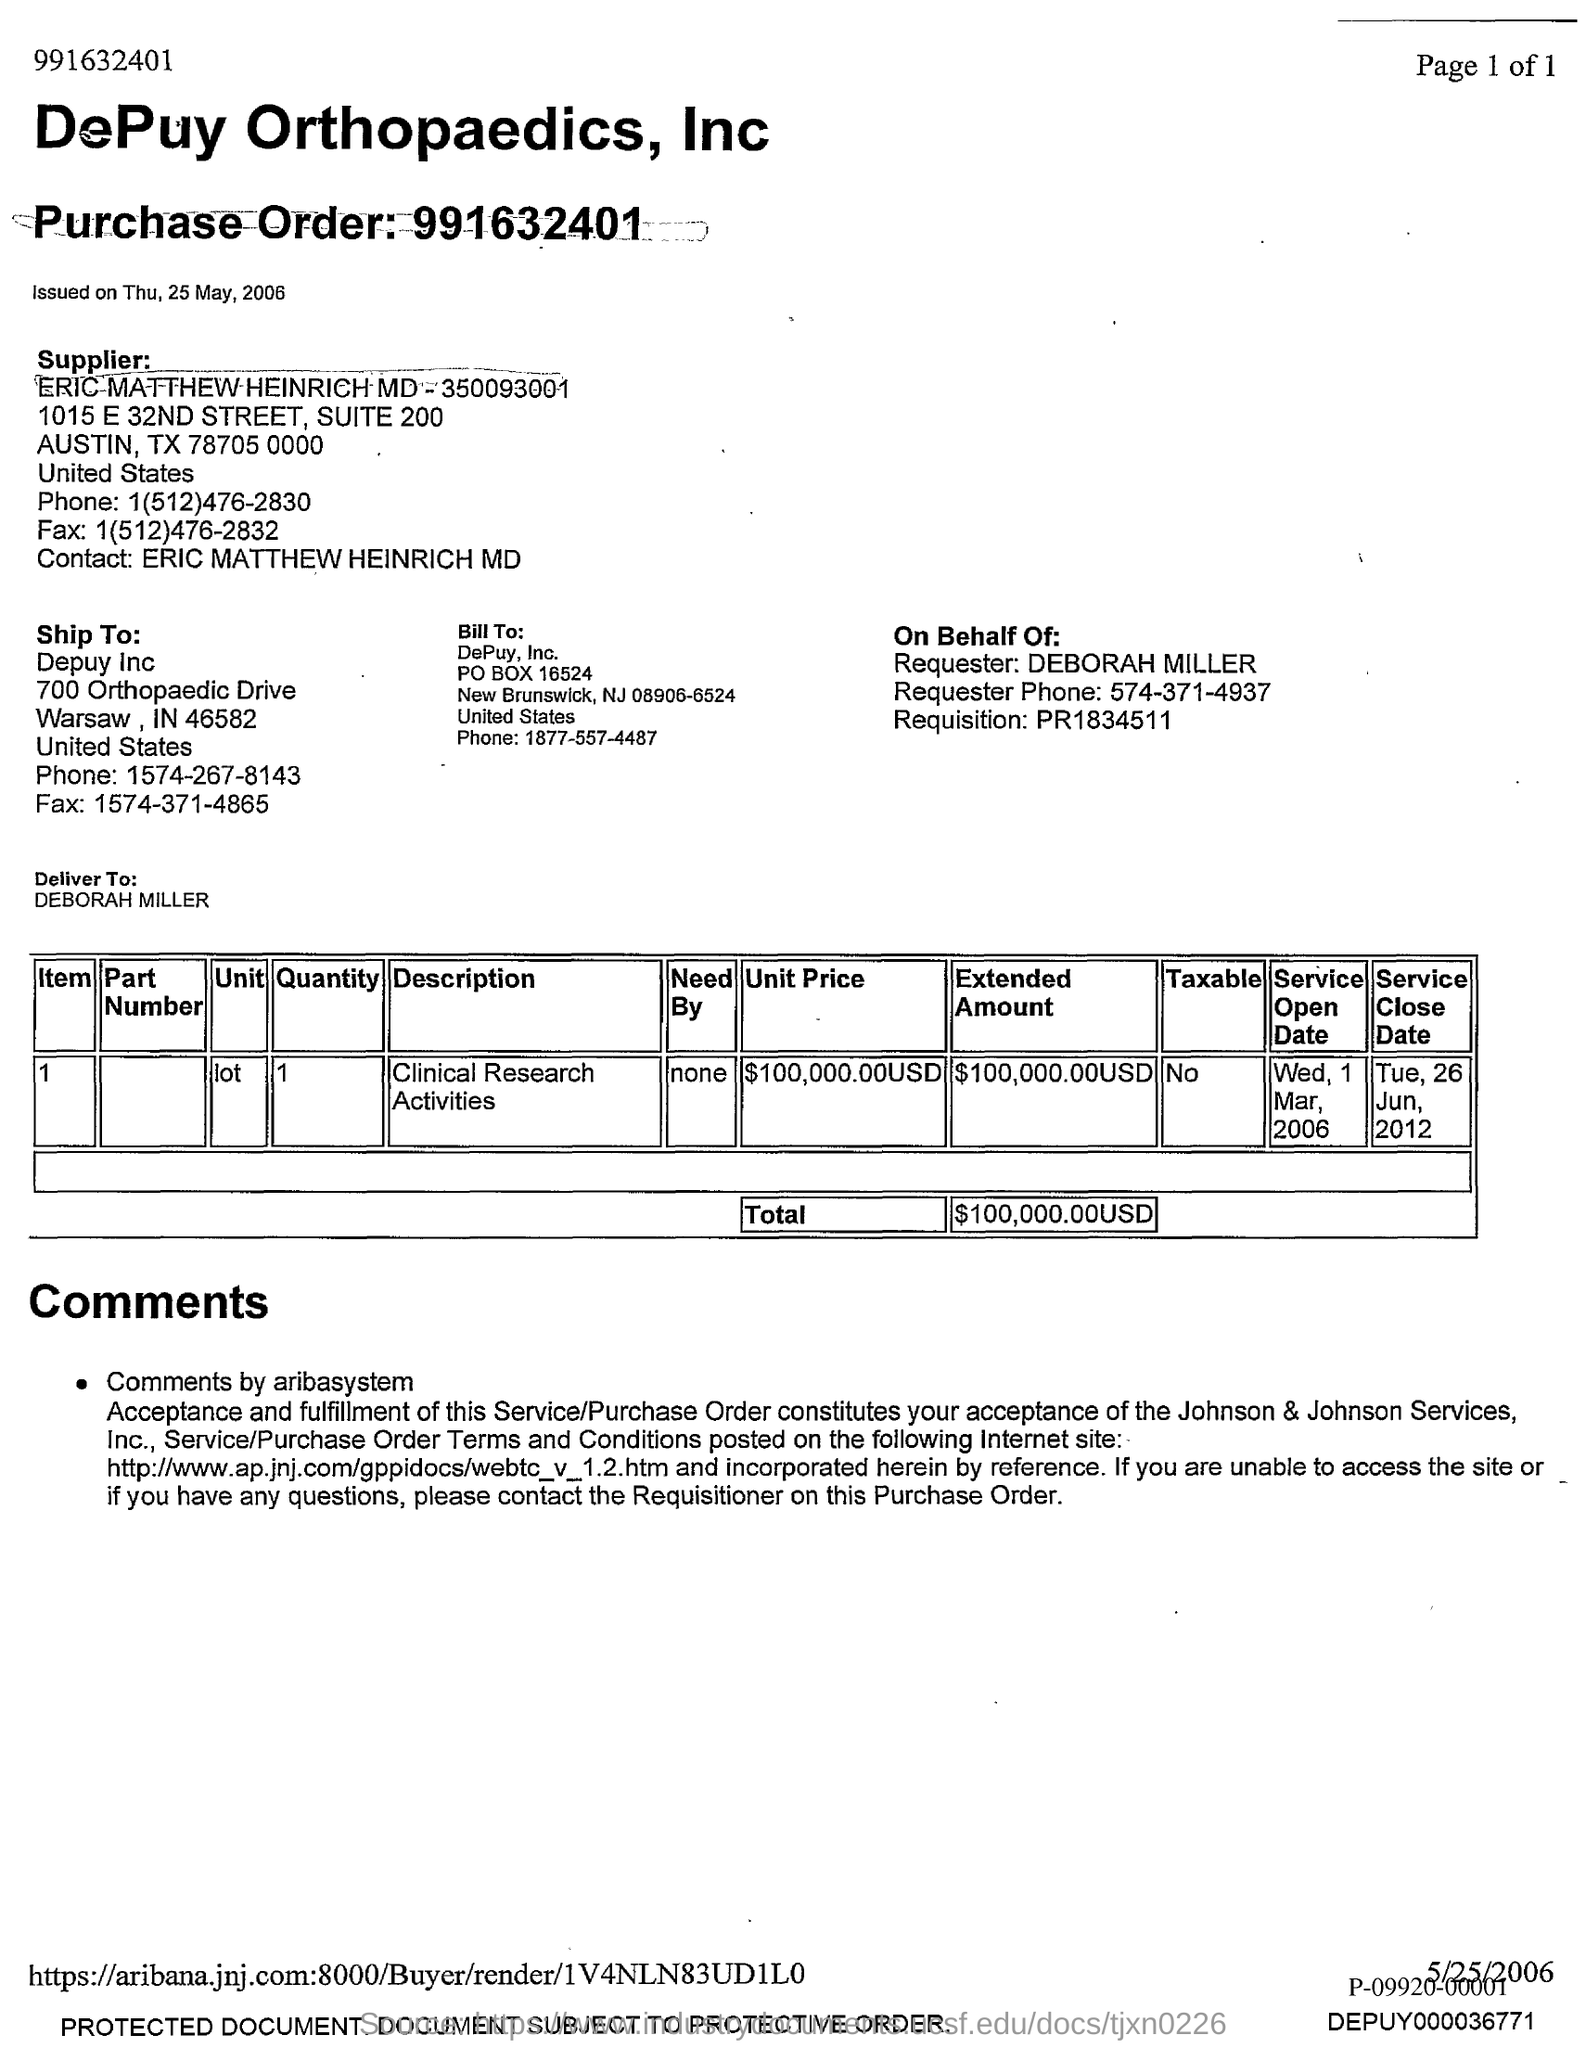Identify some key points in this picture. The ship belongs to DePuy Inc. The ticket was issued on Thursday, May 25, 2006. A purchase order is a document that outlines the details of a transaction in which a buyer purchases goods or services from a seller. The purchase order typically includes information such as the quantity and type of items being purchased, the price of each item, any special instructions or requirements for the seller, and the delivery or payment terms. The purchase order number "991632401" refers to a specific order with these details. 